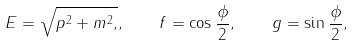Convert formula to latex. <formula><loc_0><loc_0><loc_500><loc_500>E = \sqrt { p ^ { 2 } + m ^ { 2 } , } , \, \quad f = \cos \frac { \phi } { 2 } , \, \quad g = \sin \frac { \phi } { 2 } ,</formula> 